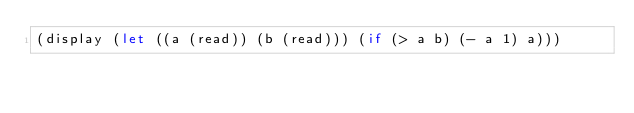Convert code to text. <code><loc_0><loc_0><loc_500><loc_500><_Scheme_>(display (let ((a (read)) (b (read))) (if (> a b) (- a 1) a)))</code> 